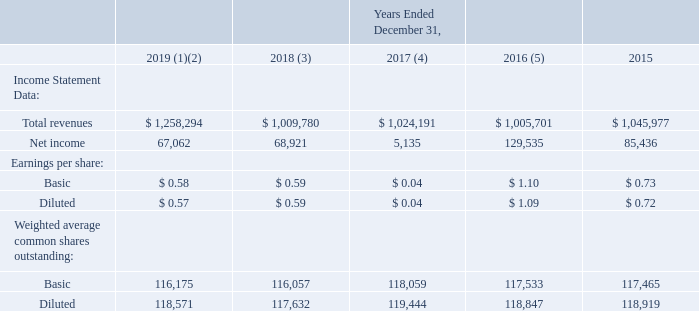ITEM 6. SELECTED FINANCIAL DATA
The following selected financial data has been derived from our consolidated financial statements (in thousands, except per share data). This data should be read together with Item 7, “Management’s Discussion and Analysis of Financial Condition and Results of Operations”, and the consolidated financial statements and related notes included elsewhere in this annual report. The financial information below is not necessarily indicative of the results of future operations. Future results could differ materially from historical results due to many factors, including those discussed in Item 1A, Risk Factors.
(1) The consolidated balance sheet and statement of operations for the year ended December 31, 2019, includes the acquisition of Speedpay as discussed in Note 3, Acquisition, to our Notes to Consolidated Financial Statements in Part IV, Item 15 of this Form 10-K.
(2) The consolidated balance sheet and statement of operations for the year ended December 31, 2019, reflects the application of Accounting Standards Update (“ASU”) 2016-02, Leases (codified as “ASC 842”) as discussed in Note 14, Leases, to our Notes to Consolidated Financial Statements.
(3) The consolidated balance sheet and statement of operations for the year ended December 31, 2018, reflects the adoption of ASU 2014-09, Revenue from Contracts with Customers (codified as “ASC 606”), as discussed in Note 2, Revenue, to our Notes to Consolidated Financial Statements, including a cumulative adjustment of $244.0 million to retained earnings.
(4) The consolidated statement of operations for the year ended December 31, 2017, reflects the Baldwin Hackett & Meeks, Inc. (“BHMI”) judgment. We recorded $46.7 million in general and administrative expense and $1.4 million in interest expense, as discussed in Note 15, Commitments and Contingencies, to our Notes to Consolidated Financial Statements.
(5) The consolidated balance sheet and statement of operations for the year ended December 31, 2016, reflects the sale of Community Financial Services assets and liabilities.
What does the consolidated balance sheet and statement of operations for the year ended December 31, 2019, include? The acquisition of speedpay. What was the total revenues in 2019?
Answer scale should be: thousand. $ 1,258,294. What was the net income in 2019?
Answer scale should be: thousand. 67,062. What was the percentage change in net income between 2018 and 2019?
Answer scale should be: percent. (67,062-68,921)/68,921
Answer: -2.7. What was the percentage change in basic earnings per share between 2017 and 2018?
Answer scale should be: percent. ($0.59-$0.04)/$0.04
Answer: 1375. What was the change in net income between 2015 and 2016?
Answer scale should be: thousand. 129,535-85,436
Answer: 44099. 